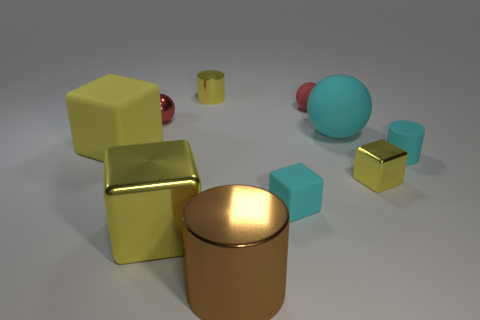What color is the matte block that is on the right side of the large shiny cylinder?
Make the answer very short. Cyan. Are there more big rubber balls that are in front of the big shiny cylinder than tiny spheres?
Your response must be concise. No. Is the shape of the red rubber object to the right of the large shiny cube the same as  the red metal thing?
Your response must be concise. Yes. What number of red objects are tiny shiny cylinders or large matte things?
Provide a succinct answer. 0. Are there more tiny purple things than tiny yellow metal objects?
Provide a succinct answer. No. There is a metal sphere that is the same size as the cyan matte cylinder; what color is it?
Your answer should be compact. Red. How many spheres are either large brown things or big objects?
Keep it short and to the point. 1. There is a brown metal object; is its shape the same as the yellow thing that is behind the red metallic ball?
Make the answer very short. Yes. What number of red metal balls are the same size as the brown cylinder?
Your answer should be compact. 0. Do the yellow shiny thing right of the big brown metal cylinder and the big metallic object in front of the large yellow shiny cube have the same shape?
Ensure brevity in your answer.  No. 